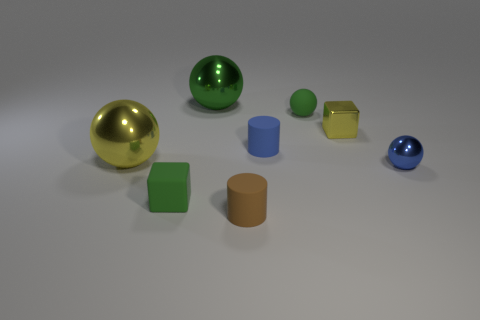Are there fewer blue things to the left of the yellow ball than small brown matte cylinders to the right of the tiny yellow shiny object?
Ensure brevity in your answer.  No. What shape is the big metallic thing to the right of the large metallic object that is in front of the large green ball?
Offer a terse response. Sphere. Is there any other thing of the same color as the tiny matte block?
Offer a terse response. Yes. Does the tiny matte block have the same color as the small metallic cube?
Your answer should be very brief. No. How many yellow objects are tiny matte spheres or metal blocks?
Offer a terse response. 1. Are there fewer large metal spheres right of the small green cube than green cylinders?
Keep it short and to the point. No. There is a rubber thing right of the blue rubber cylinder; what number of large objects are in front of it?
Your answer should be compact. 1. What number of other things are there of the same size as the matte sphere?
Make the answer very short. 5. What number of objects are yellow metal things or spheres that are in front of the yellow metal cube?
Your answer should be compact. 3. Is the number of large green metal balls less than the number of yellow rubber objects?
Make the answer very short. No. 